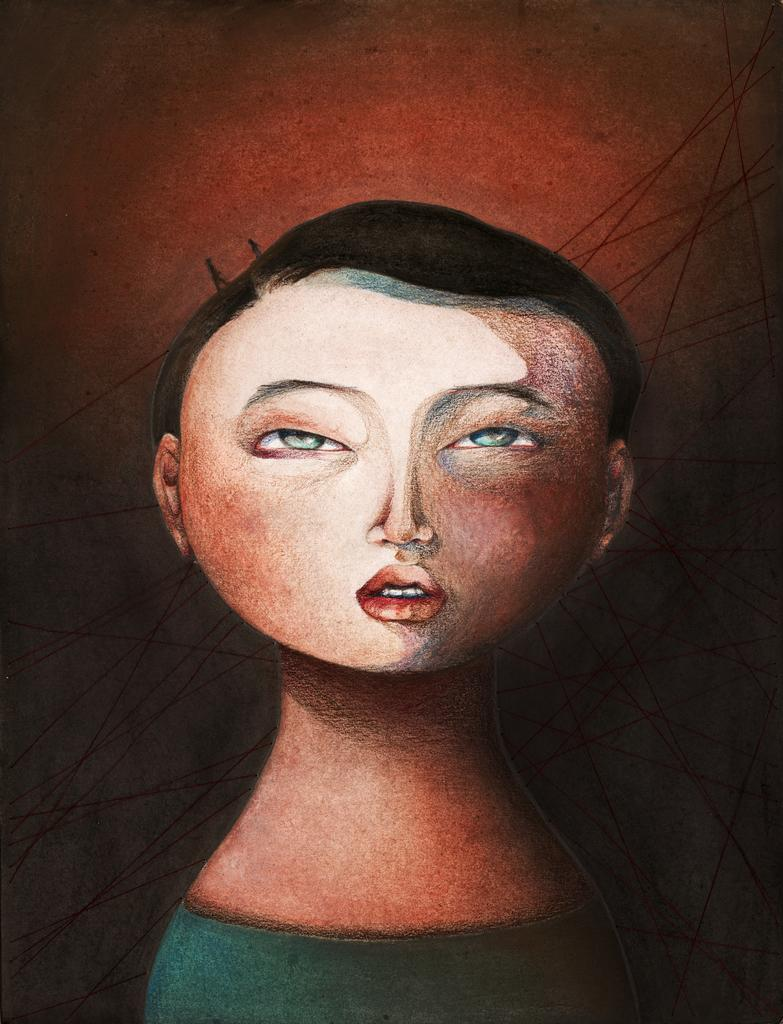What is the main subject of the painting in the image? There is a painting of a woman in the image. What can be observed about the background of the painting? The background of the image is dark in color. What type of memory does the woman have in the painting? There is no indication of the woman having a memory in the painting, as it is a static image. What activity is the woman engaged in within the painting? The painting is a static image, so it does not depict any specific activity. 